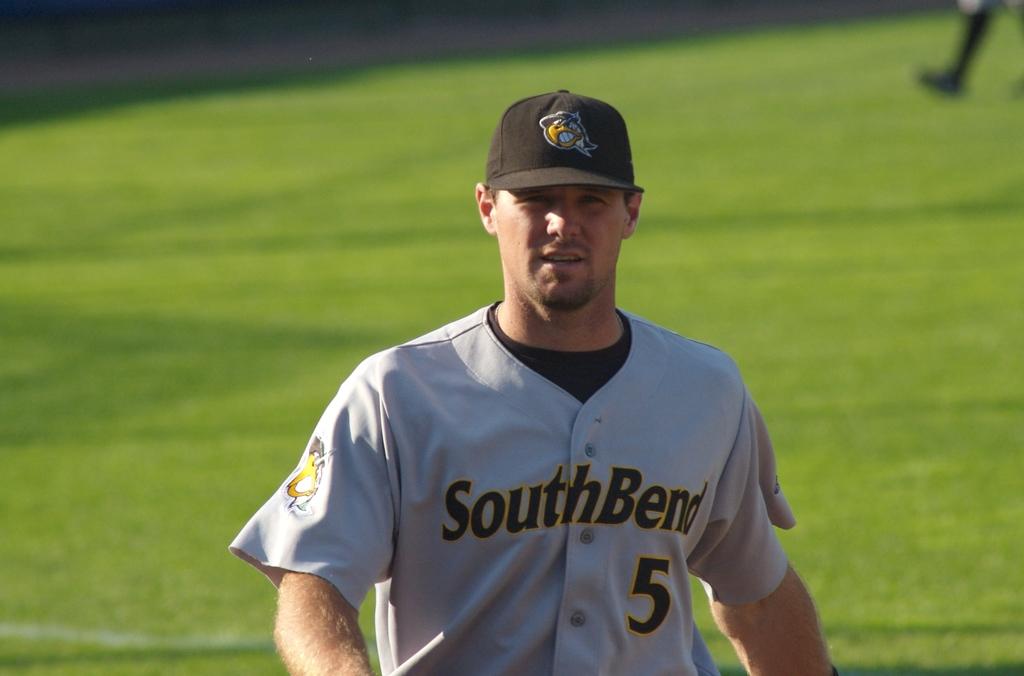What is the name of the team the player plays for?
Your answer should be very brief. Southbend. 